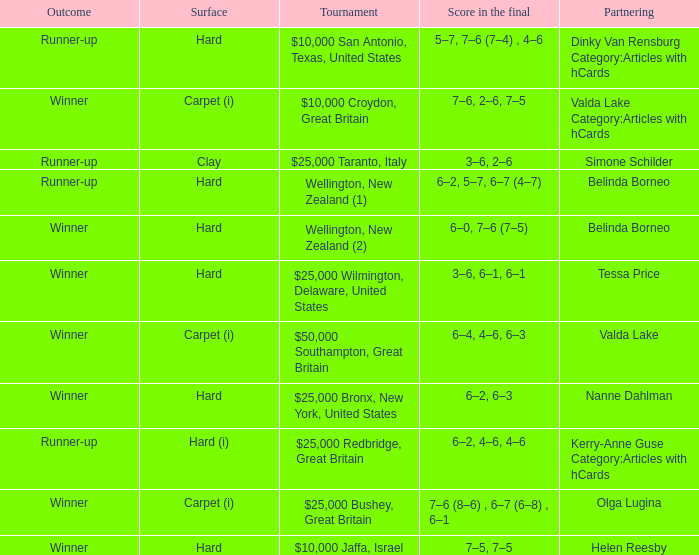What was the final score for the match with a partnering of Tessa Price? 3–6, 6–1, 6–1. 